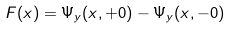Convert formula to latex. <formula><loc_0><loc_0><loc_500><loc_500>F ( x ) = \Psi _ { y } ( x , + 0 ) - \Psi _ { y } ( x , - 0 )</formula> 